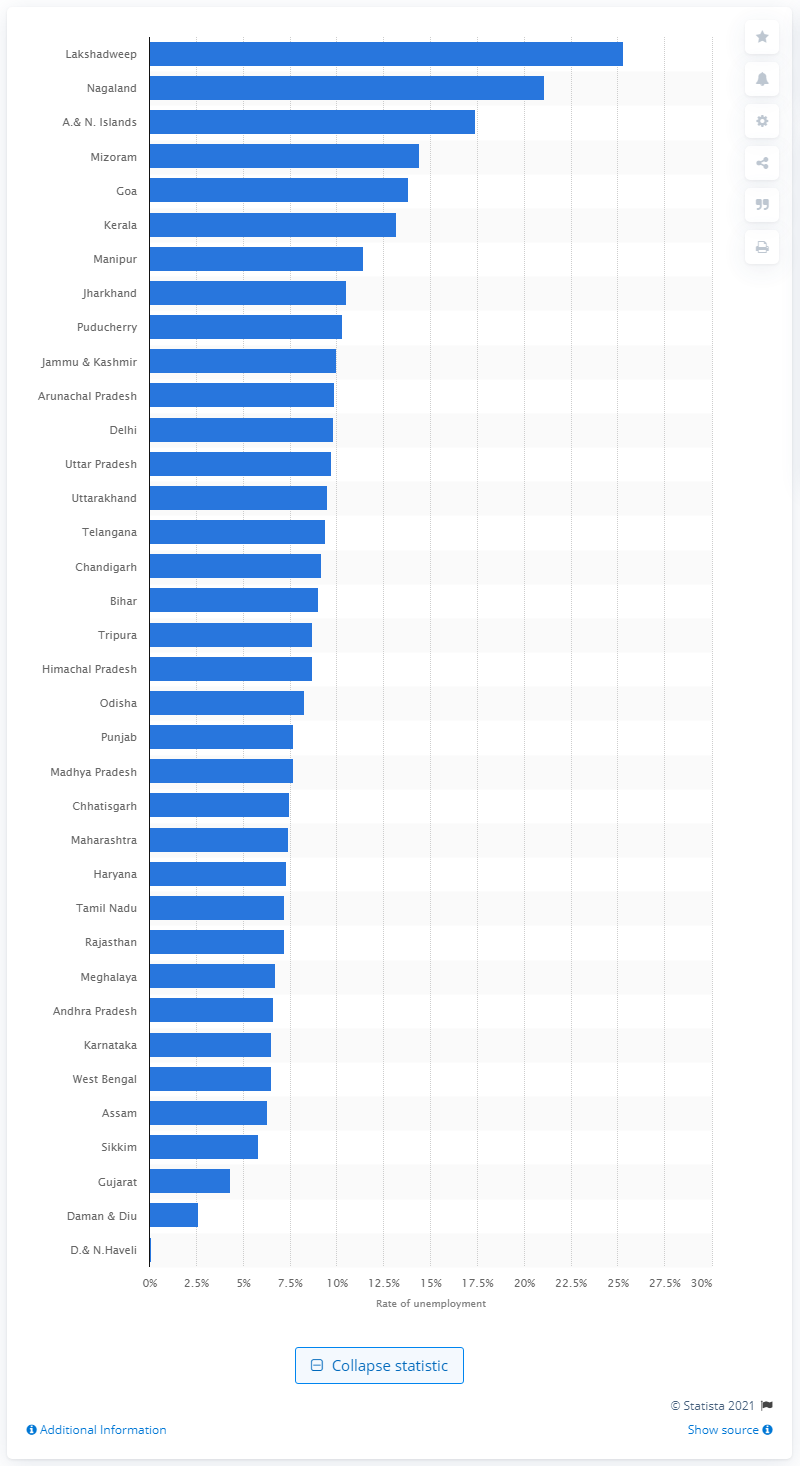Highlight a few significant elements in this photo. The unemployment rate in Lakshadweep is 25.3%. 